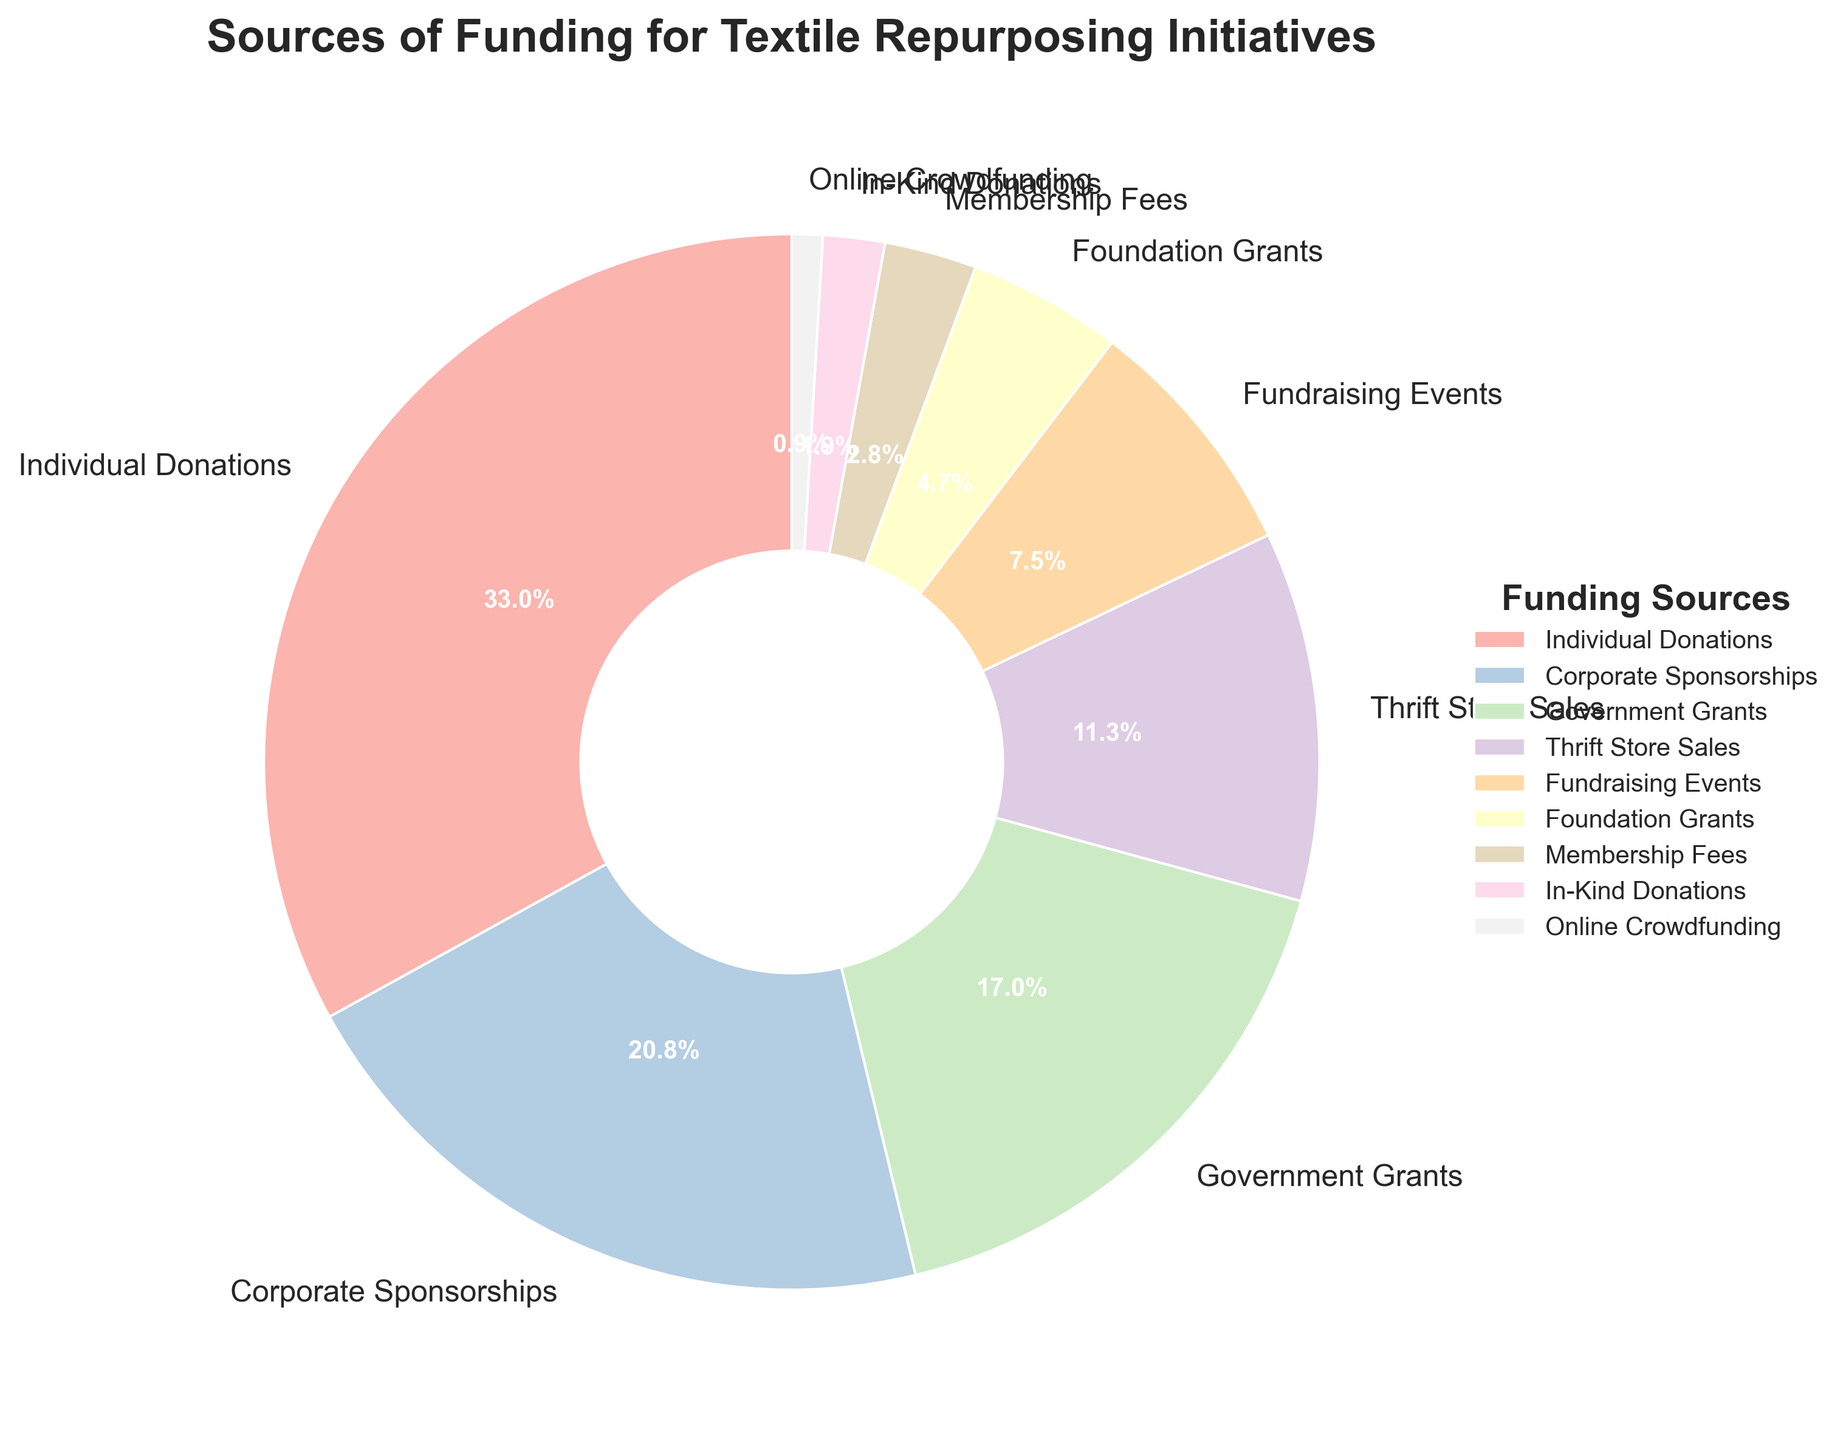Which funding source contributes the most to the nonprofit's textile repurposing initiatives? The pie chart shows that 'Individual Donations' has the largest portion of the pie, which represents the highest percentage.
Answer: Individual Donations What is the combined percentage of 'Corporate Sponsorships' and 'Government Grants'? Both 'Corporate Sponsorships' and 'Government Grants' have percentages of 22% and 18% respectively. Adding them together: 22% + 18% = 40%.
Answer: 40% How does the percentage from 'Thrift Store Sales' compare to 'Foundation Grants'? 'Thrift Store Sales' contributes 12% while 'Foundation Grants' contribute 5%. Comparing the two, 'Thrift Store Sales' has a higher percentage.
Answer: Thrift Store Sales Which three funding sources contribute the least, in total percentage? Adding percentages for 'In-Kind Donations', 'Online Crowdfunding', and 'Membership Fees': 2% + 1% + 3% = 6%.
Answer: Online Crowdfunding, In-Kind Donations, Membership Fees Is the percentage from 'Fundraising Events' greater than the combined percentage of 'In-Kind Donations' and 'Online Crowdfunding'? 'Fundraising Events' have a percentage of 8%, while the combined percentage for 'In-Kind Donations' and 'Online Crowdfunding' is 2% + 1% = 3%. 8% is greater than 3%.
Answer: Yes What percentage of funding comes from sources related to direct sales (Thrift Store Sales + Membership Fees)? Adding percentages for 'Thrift Store Sales' and 'Membership Fees': 12% + 3% = 15%.
Answer: 15% Identify the funding source that contributes just below 'Corporate Sponsorships' in percentage. 'Government Grants' contributes 18%, which is just below 'Corporate Sponsorships' at 22%.
Answer: Government Grants Calculate the difference in percentage between 'Individual Donations' and the next largest funding source. 'Individual Donations' contribute 35%, and the next largest ('Corporate Sponsorships') contribute 22%. The difference: 35% - 22% = 13%.
Answer: 13% How many funding sources contribute less than 10%? The pie chart shows four segments contributing less than 10%: 'Fundraising Events' (8%), 'Foundation Grants' (5%), 'Membership Fees' (3%), and 'In-Kind Donations' (2%).
Answer: 4 What is the visual representation color of 'Government Grants' in the pie chart? 'Government Grants' is represented by a specific color in the pie chart, possibly pastel shades given the color palette used.
Answer: (The specific color must be provided by viewing the image) 